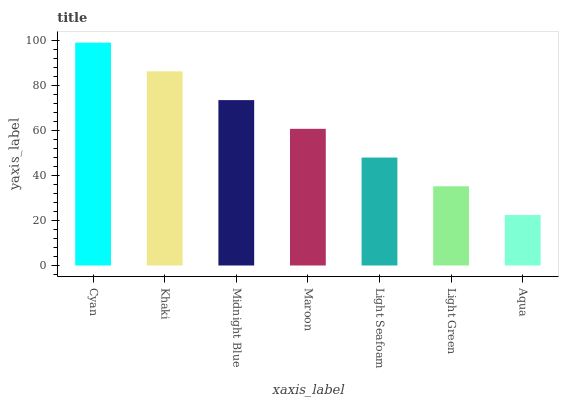Is Khaki the minimum?
Answer yes or no. No. Is Khaki the maximum?
Answer yes or no. No. Is Cyan greater than Khaki?
Answer yes or no. Yes. Is Khaki less than Cyan?
Answer yes or no. Yes. Is Khaki greater than Cyan?
Answer yes or no. No. Is Cyan less than Khaki?
Answer yes or no. No. Is Maroon the high median?
Answer yes or no. Yes. Is Maroon the low median?
Answer yes or no. Yes. Is Aqua the high median?
Answer yes or no. No. Is Midnight Blue the low median?
Answer yes or no. No. 